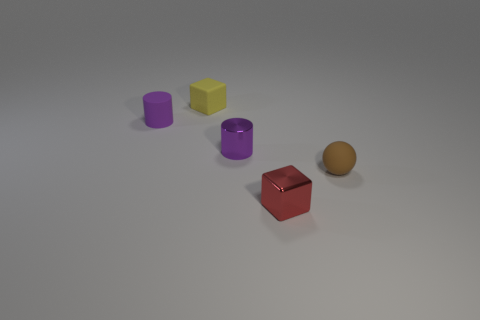Add 3 blocks. How many objects exist? 8 Subtract all cylinders. How many objects are left? 3 Subtract 0 blue blocks. How many objects are left? 5 Subtract all small metal cubes. Subtract all tiny yellow rubber cubes. How many objects are left? 3 Add 3 tiny yellow rubber objects. How many tiny yellow rubber objects are left? 4 Add 4 gray cylinders. How many gray cylinders exist? 4 